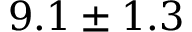Convert formula to latex. <formula><loc_0><loc_0><loc_500><loc_500>9 . 1 \pm 1 . 3</formula> 